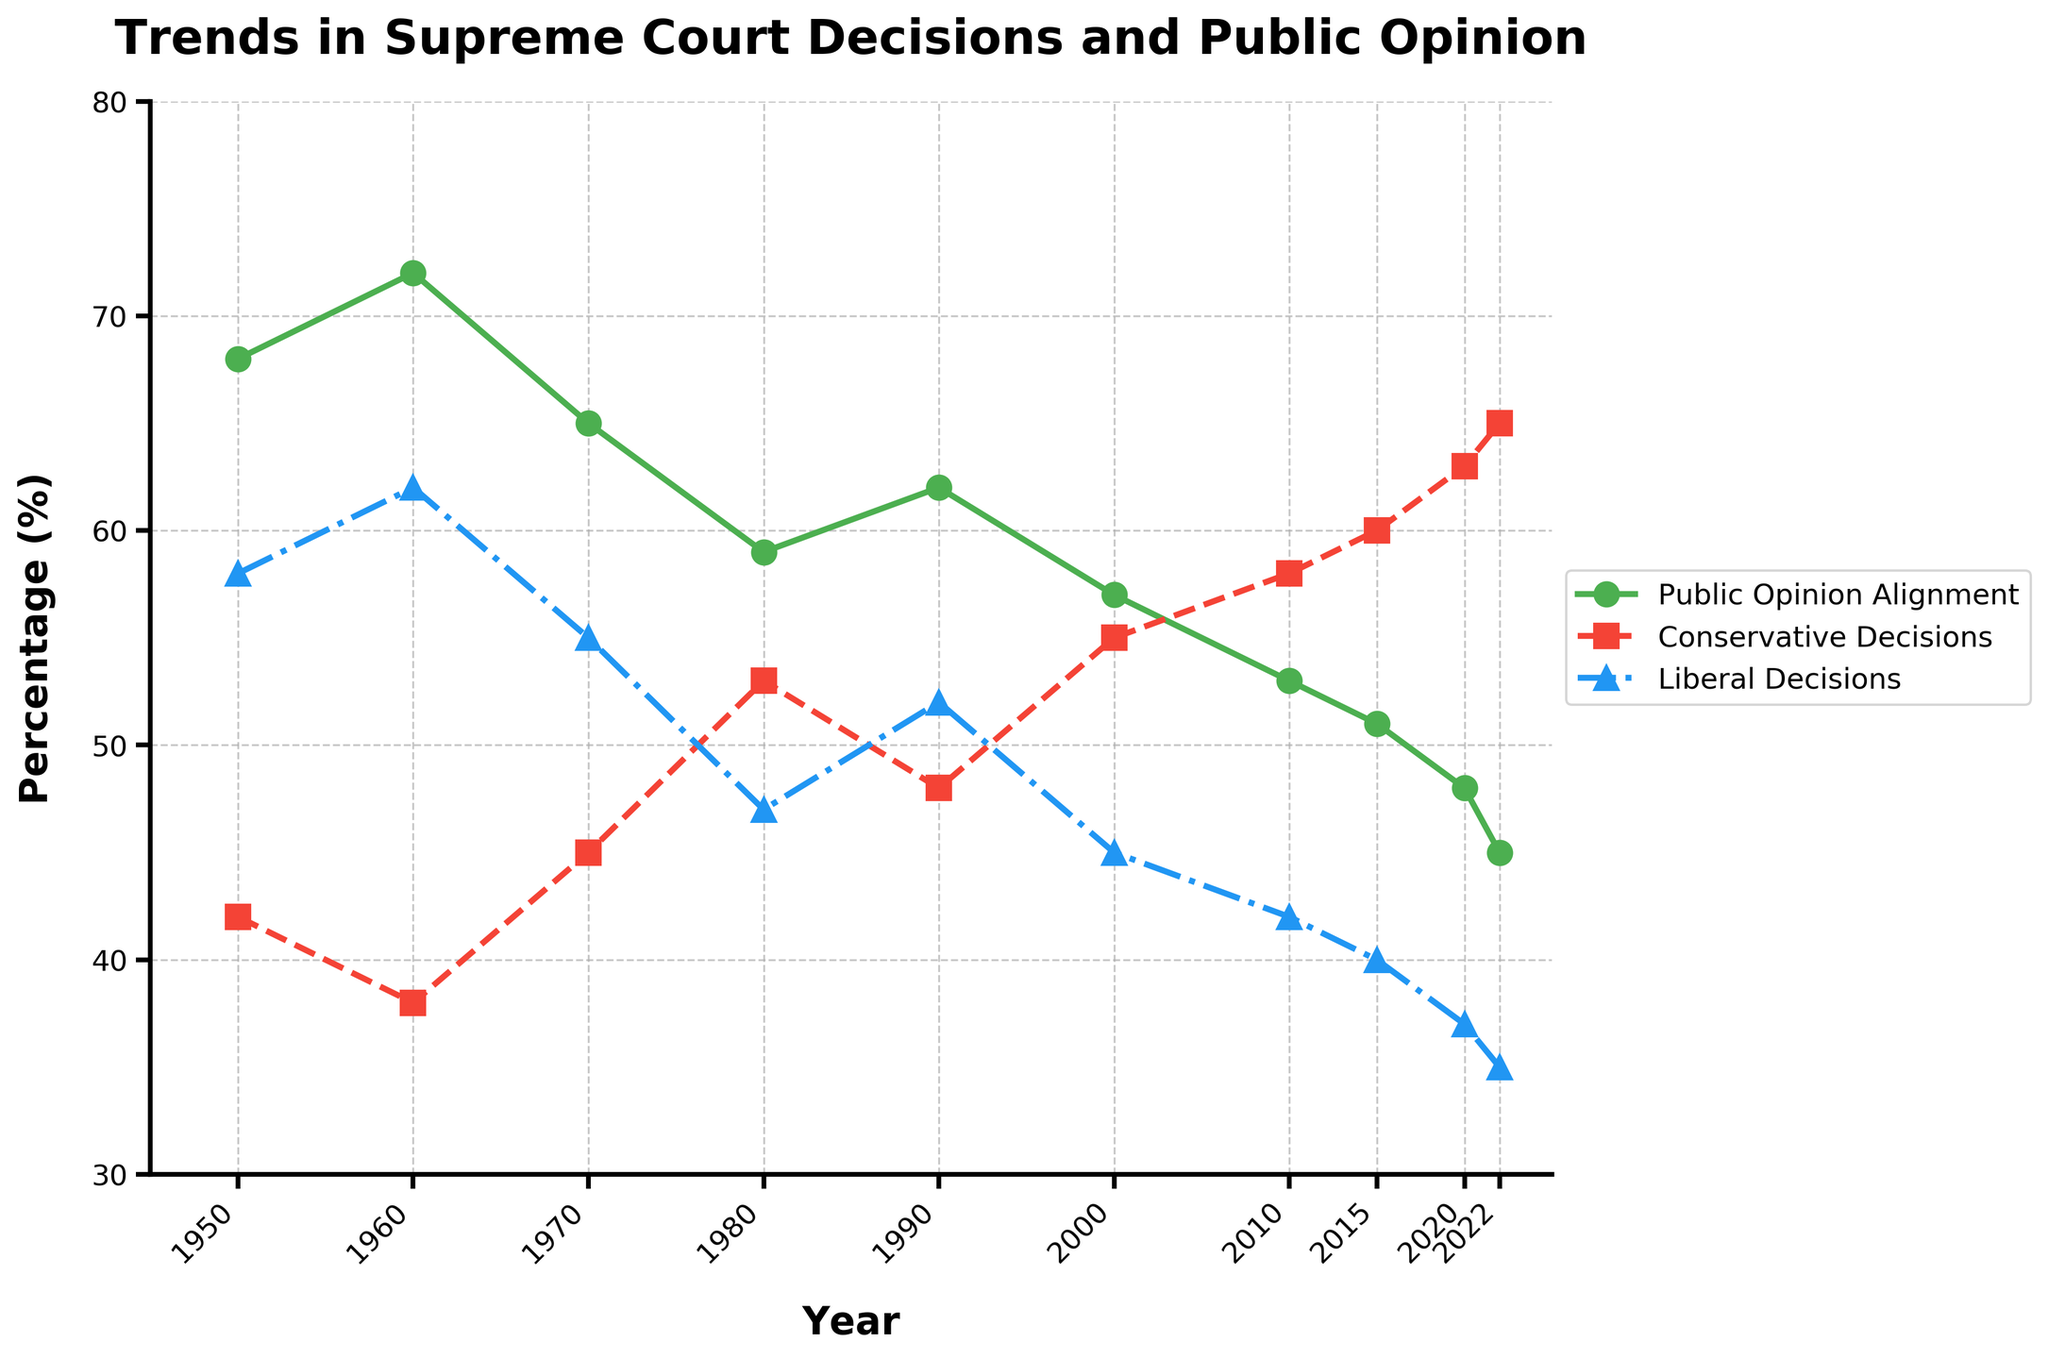**Question 1**: What year had the highest alignment with public opinion? To determine this, we need to look at the peaks of the green line representing Public Opinion Alignment (%). By following the green line, we can see that it is highest in the year 1960.
Answer: 1960 **Question 2**: What is the average percentage of Conservative Decisions from 2000 to 2022? We sum the percentages for the years 2000, 2010, 2015, 2020, and 2022 and then divide by the number of years. The sum is (55 + 58 + 60 + 63 + 65) = 301, and there are 5 data points. So, the average is 301/5 = 60.2.
Answer: 60.2 **Question 3**: How has the alignment with public opinion trended from 1950 to 2022? To understand the trend, follow the green line from left to right. It starts at 68% in 1950 and ends at 45% in 2022, showing a steady decline over time.
Answer: Decreasing **Question 4**: In 1980, which percentage is higher: Conservative Decisions or Liberal Decisions? In the year 1980, the red and blue lines intersect. Following both lines, we note that Conservative Decisions are at 53% while Liberal Decisions are at 47%.
Answer: Conservative Decisions **Question 5**: By how much did the percentage of Public Opinion Alignment decrease from 1970 to 2022? The Public Opinion Alignment was 65% in 1970 and 45% in 2022. The decrease is calculated as 65 - 45 = 20.
Answer: 20 **Question 6**: Which year saw the greatest difference between Conservative and Liberal Decisions? We need to check the magnitude of differences between the red and blue lines in the figure. The greatest difference is observed in 2022, with Conservative Decisions at 65% and Liberal Decisions at 35%, resulting in a difference of 30%.
Answer: 2022 **Question 7**: What trend can be observed in the percentage of Liberal Decisions from 2000 to 2022? Observing the blue line from 2000 onward, we see that the percentage of Liberal Decisions consistently decreases from 45% in 2000 to 35% in 2022.
Answer: Decreasing **Question 8**: What is the combined percentage of Conservative and Liberal Decisions in 2015? The percentage of Conservative Decisions in 2015 is 60%, and the percentage of Liberal Decisions is 40%. The combined percentage is 60 + 40 = 100.
Answer: 100 **Question 9**: Was the alignment with public opinion higher or lower in 2010 compared to 2020? Looking at the green line in the years 2010 and 2020, we see that in 2010, alignment is at 53%, while in 2020, it is at 48%. So, it was higher in 2010.
Answer: Higher 